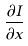Convert formula to latex. <formula><loc_0><loc_0><loc_500><loc_500>\frac { \partial I } { \partial x }</formula> 